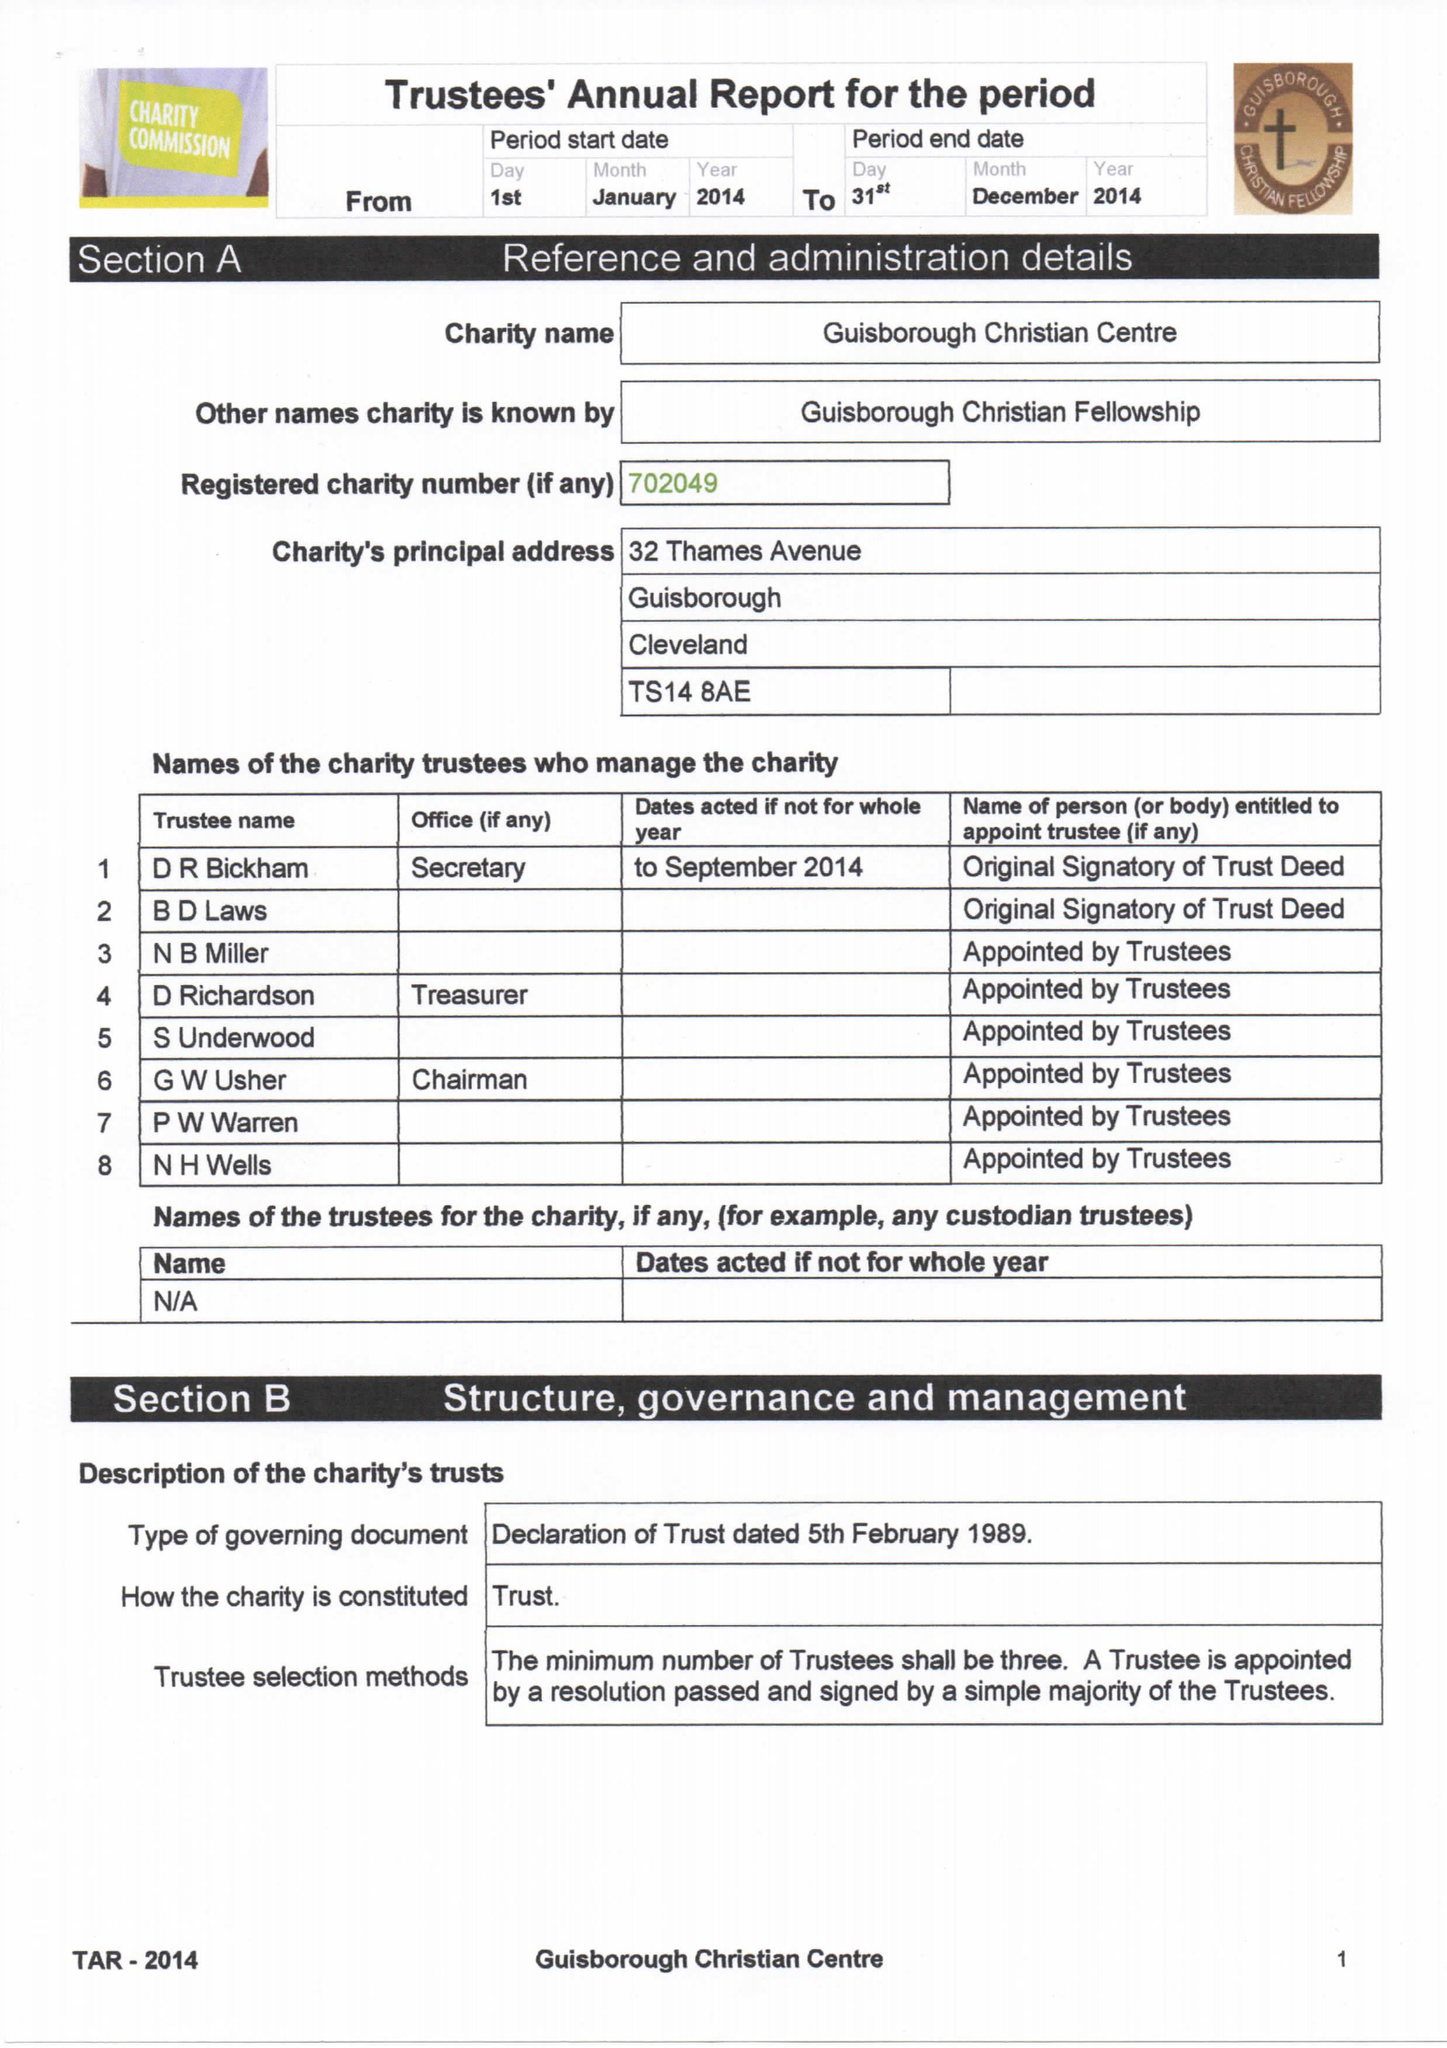What is the value for the income_annually_in_british_pounds?
Answer the question using a single word or phrase. 35834.00 